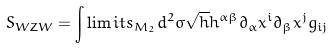<formula> <loc_0><loc_0><loc_500><loc_500>S _ { W Z W } = \int \lim i t s _ { M _ { 2 } } d ^ { 2 } \sigma \sqrt { h } h ^ { \alpha \beta } \partial _ { \alpha } x ^ { i } \partial _ { \beta } x ^ { j } g _ { i j }</formula> 